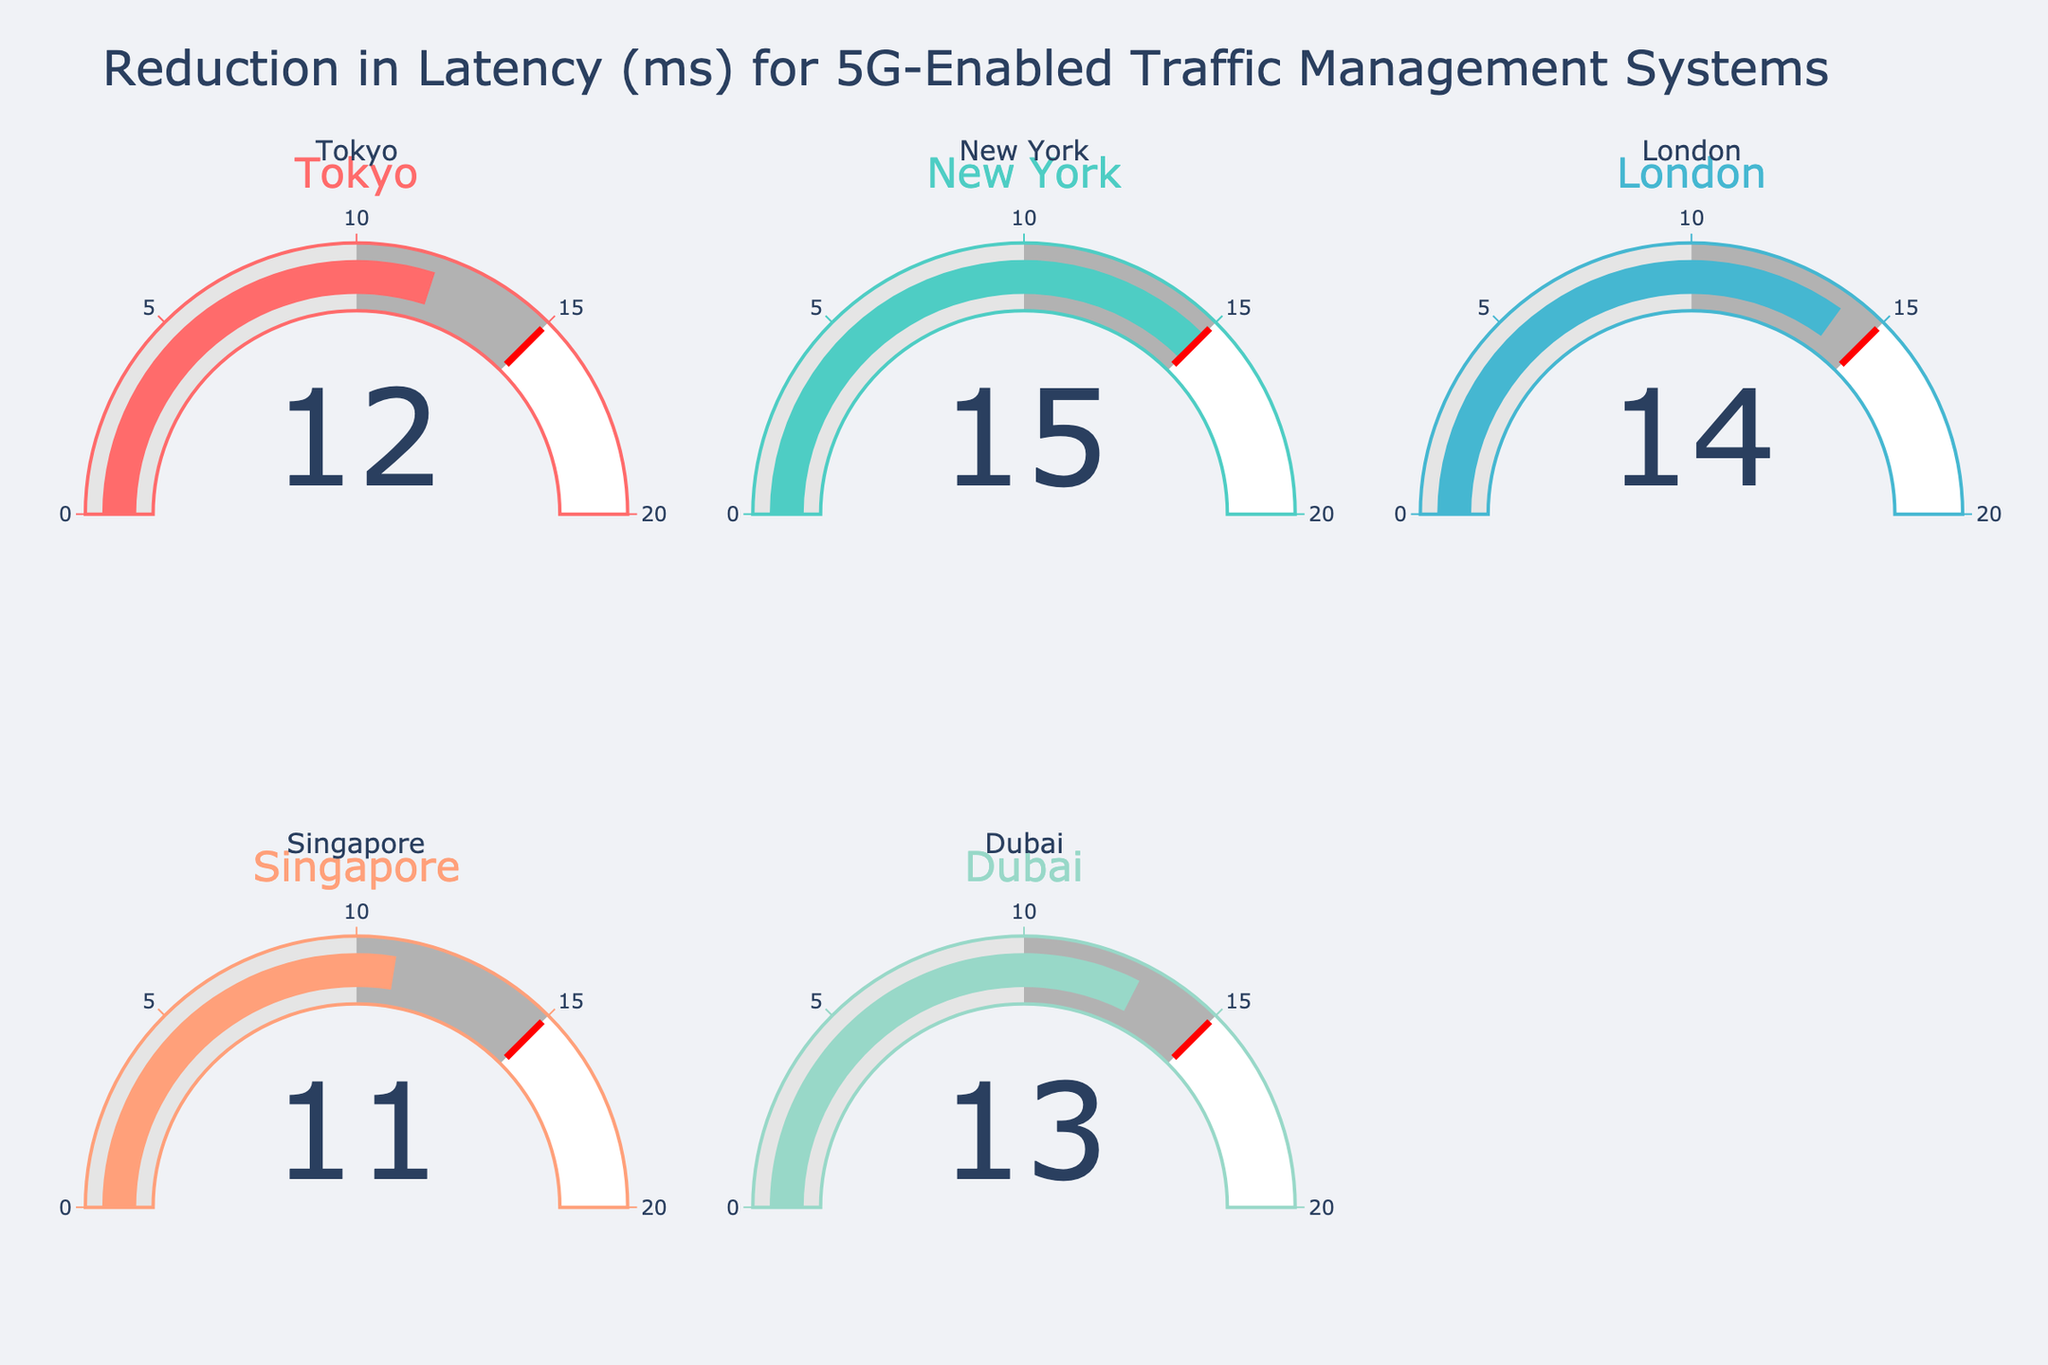How many cities are represented in the chart? By visually counting the number of gauge charts, it shows that there are five cities represented: Tokyo, New York, London, Singapore, and Dubai.
Answer: 5 Which city has the highest latency reduction value? By examining the values displayed on each gauge, New York has the highest latency reduction value of 15 ms.
Answer: New York What is the range of latency reduction values depicted in the chart? The latency reduction values range from the minimum value (Singapore at 11 ms) to the maximum value (New York at 15 ms).
Answer: 11 ms to 15 ms What is the combined latency reduction for Tokyo and Dubai? By adding the latency reduction values for Tokyo (12 ms) and Dubai (13 ms), the combined reduction is 12 + 13.
Answer: 25 ms How does the latency reduction in Singapore compare to those in London and Dubai? Singapore's latency reduction is 11 ms, which is lower than both London's (14 ms) and Dubai's (13 ms).
Answer: Lower Is there any city that has a latency reduction value exactly equal to the set threshold of 15 ms? By examining the threshold marker and the values displayed, New York is the only city with a latency reduction of exactly 15 ms.
Answer: Yes What is the average latency reduction across all cities? Adding all the latency values (12 + 15 + 14 + 11 + 13) and dividing by the number of cities, which is 5, the average is 65/5.
Answer: 13 ms Which city has the smallest latency reduction, and by how much is it smaller than the biggest reduction? Singapore has the smallest latency reduction of 11 ms. The biggest reduction is in New York (15 ms). The difference is 15 - 11.
Answer: 4 ms How many cities have a latency reduction value greater than 12 ms? By examining the data, three cities have latency reductions greater than 12 ms: New York (15), London (14), and Dubai (13).
Answer: 3 If the reduction in latency were to increase by 5 ms for each city, which city would then have the highest latency reduction value? Adding 5 ms to each city's current latency reduction: Tokyo (17), New York (20), London (19), Singapore (16), and Dubai (18). New York would have the highest value of 20 ms.
Answer: New York 